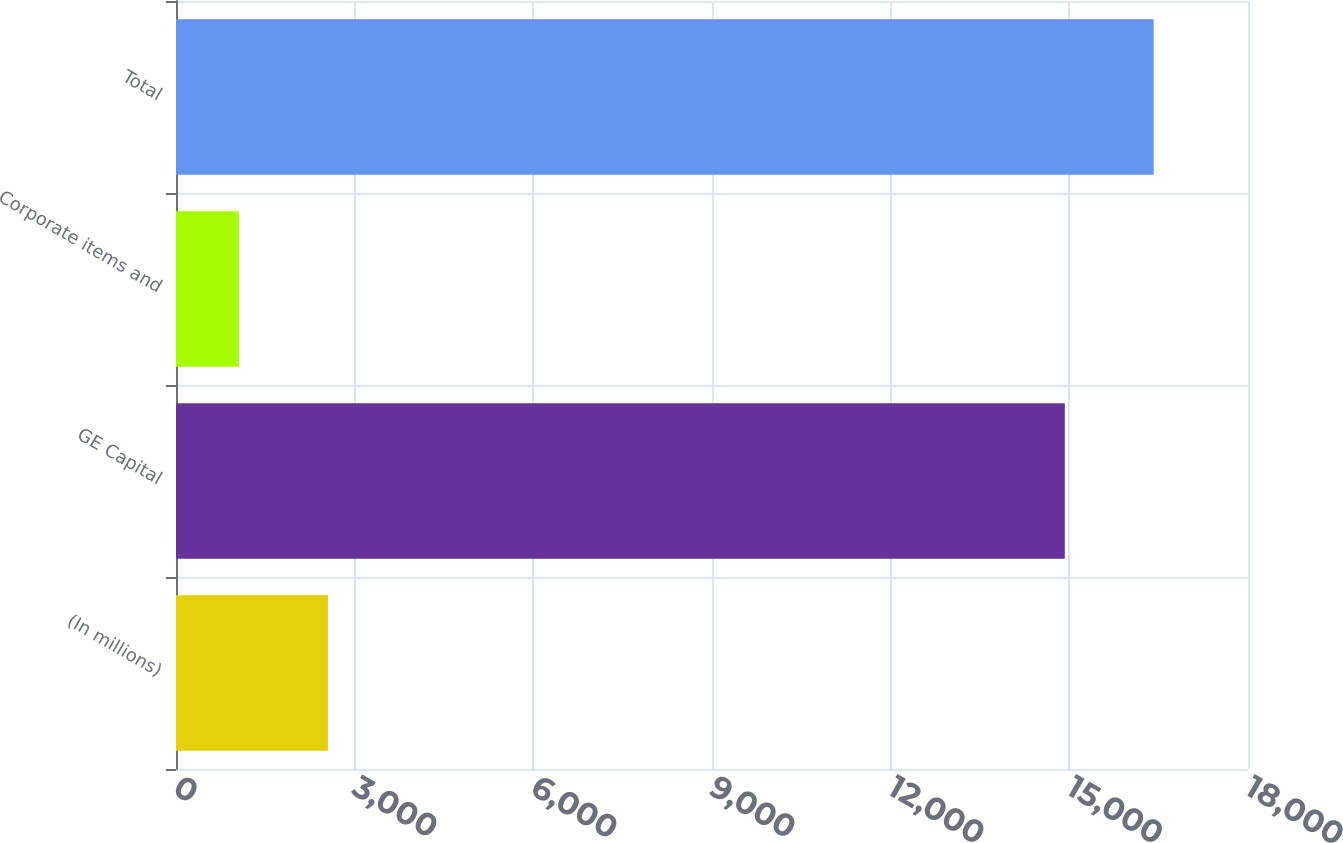Convert chart. <chart><loc_0><loc_0><loc_500><loc_500><bar_chart><fcel>(In millions)<fcel>GE Capital<fcel>Corporate items and<fcel>Total<nl><fcel>2551.4<fcel>14924<fcel>1059<fcel>16416.4<nl></chart> 